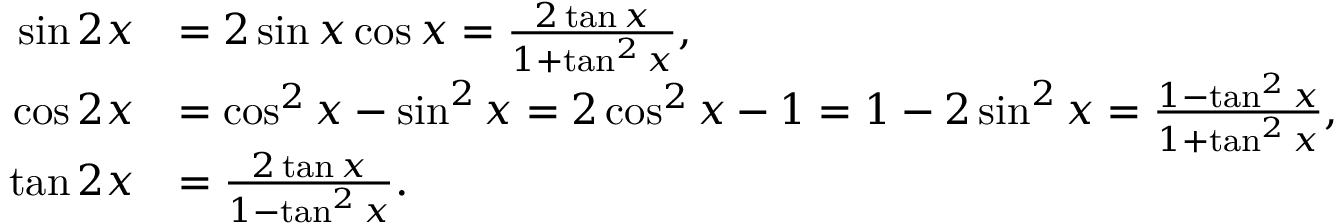<formula> <loc_0><loc_0><loc_500><loc_500>{ \begin{array} { r l } { \sin 2 x } & { = 2 \sin x \cos x = { \frac { 2 \tan x } { 1 + \tan ^ { 2 } x } } , } \\ { \cos 2 x } & { = \cos ^ { 2 } x - \sin ^ { 2 } x = 2 \cos ^ { 2 } x - 1 = 1 - 2 \sin ^ { 2 } x = { \frac { 1 - \tan ^ { 2 } x } { 1 + \tan ^ { 2 } x } } , } \\ { \tan 2 x } & { = { \frac { 2 \tan x } { 1 - \tan ^ { 2 } x } } . } \end{array} }</formula> 